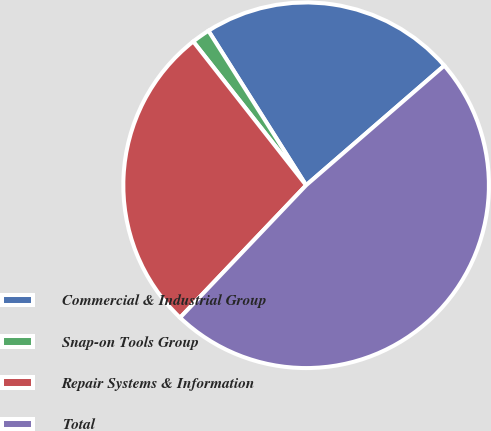<chart> <loc_0><loc_0><loc_500><loc_500><pie_chart><fcel>Commercial & Industrial Group<fcel>Snap-on Tools Group<fcel>Repair Systems & Information<fcel>Total<nl><fcel>22.62%<fcel>1.62%<fcel>27.3%<fcel>48.47%<nl></chart> 